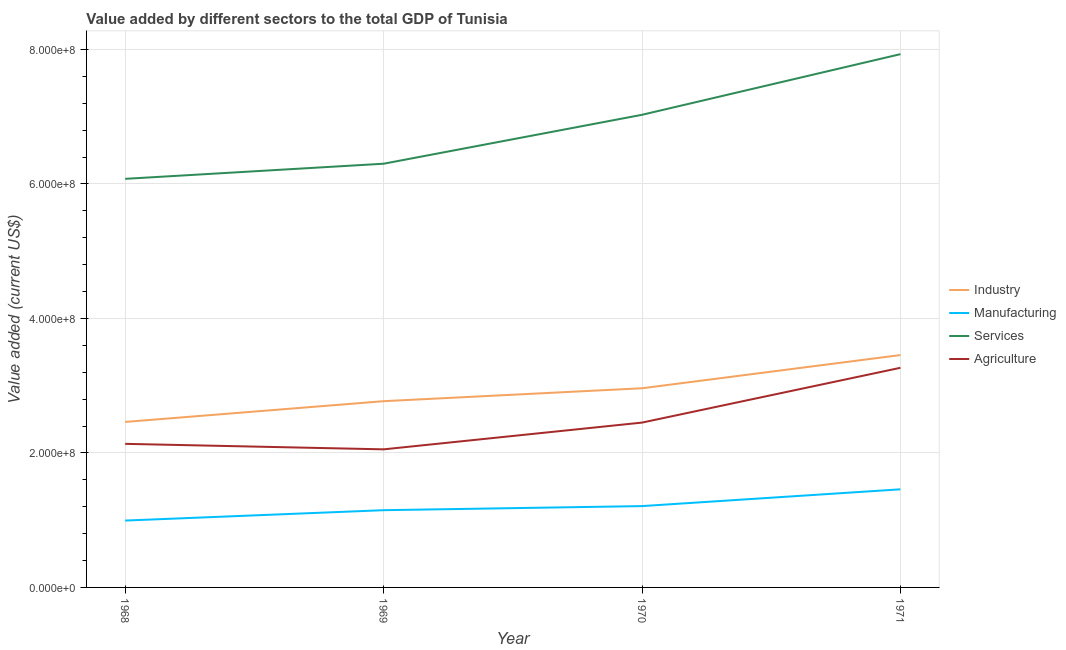Does the line corresponding to value added by services sector intersect with the line corresponding to value added by agricultural sector?
Your response must be concise. No. Is the number of lines equal to the number of legend labels?
Provide a succinct answer. Yes. What is the value added by manufacturing sector in 1968?
Keep it short and to the point. 9.94e+07. Across all years, what is the maximum value added by agricultural sector?
Give a very brief answer. 3.27e+08. Across all years, what is the minimum value added by manufacturing sector?
Give a very brief answer. 9.94e+07. In which year was the value added by manufacturing sector minimum?
Provide a short and direct response. 1968. What is the total value added by manufacturing sector in the graph?
Your answer should be very brief. 4.81e+08. What is the difference between the value added by agricultural sector in 1968 and that in 1970?
Provide a short and direct response. -3.16e+07. What is the difference between the value added by agricultural sector in 1971 and the value added by services sector in 1968?
Your response must be concise. -2.81e+08. What is the average value added by industrial sector per year?
Your answer should be very brief. 2.91e+08. In the year 1968, what is the difference between the value added by manufacturing sector and value added by services sector?
Give a very brief answer. -5.08e+08. What is the ratio of the value added by industrial sector in 1969 to that in 1971?
Your answer should be very brief. 0.8. Is the value added by agricultural sector in 1968 less than that in 1970?
Give a very brief answer. Yes. Is the difference between the value added by manufacturing sector in 1968 and 1969 greater than the difference between the value added by industrial sector in 1968 and 1969?
Offer a very short reply. Yes. What is the difference between the highest and the second highest value added by services sector?
Your response must be concise. 9.02e+07. What is the difference between the highest and the lowest value added by industrial sector?
Your response must be concise. 9.95e+07. In how many years, is the value added by agricultural sector greater than the average value added by agricultural sector taken over all years?
Offer a terse response. 1. Is the sum of the value added by services sector in 1969 and 1970 greater than the maximum value added by agricultural sector across all years?
Keep it short and to the point. Yes. Is it the case that in every year, the sum of the value added by agricultural sector and value added by services sector is greater than the sum of value added by manufacturing sector and value added by industrial sector?
Give a very brief answer. Yes. Is the value added by industrial sector strictly greater than the value added by services sector over the years?
Offer a terse response. No. How many years are there in the graph?
Keep it short and to the point. 4. What is the difference between two consecutive major ticks on the Y-axis?
Ensure brevity in your answer.  2.00e+08. Does the graph contain any zero values?
Ensure brevity in your answer.  No. Does the graph contain grids?
Offer a very short reply. Yes. How many legend labels are there?
Ensure brevity in your answer.  4. What is the title of the graph?
Make the answer very short. Value added by different sectors to the total GDP of Tunisia. What is the label or title of the Y-axis?
Your response must be concise. Value added (current US$). What is the Value added (current US$) of Industry in 1968?
Your answer should be compact. 2.46e+08. What is the Value added (current US$) of Manufacturing in 1968?
Ensure brevity in your answer.  9.94e+07. What is the Value added (current US$) of Services in 1968?
Make the answer very short. 6.08e+08. What is the Value added (current US$) of Agriculture in 1968?
Provide a succinct answer. 2.14e+08. What is the Value added (current US$) in Industry in 1969?
Make the answer very short. 2.77e+08. What is the Value added (current US$) in Manufacturing in 1969?
Give a very brief answer. 1.15e+08. What is the Value added (current US$) in Services in 1969?
Make the answer very short. 6.30e+08. What is the Value added (current US$) in Agriculture in 1969?
Your answer should be very brief. 2.05e+08. What is the Value added (current US$) in Industry in 1970?
Make the answer very short. 2.96e+08. What is the Value added (current US$) of Manufacturing in 1970?
Offer a terse response. 1.21e+08. What is the Value added (current US$) in Services in 1970?
Your answer should be very brief. 7.03e+08. What is the Value added (current US$) of Agriculture in 1970?
Provide a succinct answer. 2.45e+08. What is the Value added (current US$) in Industry in 1971?
Make the answer very short. 3.46e+08. What is the Value added (current US$) in Manufacturing in 1971?
Provide a succinct answer. 1.46e+08. What is the Value added (current US$) in Services in 1971?
Your response must be concise. 7.93e+08. What is the Value added (current US$) of Agriculture in 1971?
Ensure brevity in your answer.  3.27e+08. Across all years, what is the maximum Value added (current US$) of Industry?
Give a very brief answer. 3.46e+08. Across all years, what is the maximum Value added (current US$) of Manufacturing?
Give a very brief answer. 1.46e+08. Across all years, what is the maximum Value added (current US$) in Services?
Offer a terse response. 7.93e+08. Across all years, what is the maximum Value added (current US$) of Agriculture?
Ensure brevity in your answer.  3.27e+08. Across all years, what is the minimum Value added (current US$) of Industry?
Give a very brief answer. 2.46e+08. Across all years, what is the minimum Value added (current US$) in Manufacturing?
Give a very brief answer. 9.94e+07. Across all years, what is the minimum Value added (current US$) in Services?
Keep it short and to the point. 6.08e+08. Across all years, what is the minimum Value added (current US$) in Agriculture?
Provide a short and direct response. 2.05e+08. What is the total Value added (current US$) in Industry in the graph?
Offer a terse response. 1.16e+09. What is the total Value added (current US$) of Manufacturing in the graph?
Offer a terse response. 4.81e+08. What is the total Value added (current US$) of Services in the graph?
Offer a terse response. 2.73e+09. What is the total Value added (current US$) in Agriculture in the graph?
Offer a very short reply. 9.91e+08. What is the difference between the Value added (current US$) in Industry in 1968 and that in 1969?
Your answer should be very brief. -3.09e+07. What is the difference between the Value added (current US$) of Manufacturing in 1968 and that in 1969?
Offer a very short reply. -1.54e+07. What is the difference between the Value added (current US$) of Services in 1968 and that in 1969?
Make the answer very short. -2.25e+07. What is the difference between the Value added (current US$) of Agriculture in 1968 and that in 1969?
Make the answer very short. 8.19e+06. What is the difference between the Value added (current US$) in Industry in 1968 and that in 1970?
Your answer should be compact. -5.01e+07. What is the difference between the Value added (current US$) in Manufacturing in 1968 and that in 1970?
Your answer should be very brief. -2.15e+07. What is the difference between the Value added (current US$) of Services in 1968 and that in 1970?
Your response must be concise. -9.52e+07. What is the difference between the Value added (current US$) of Agriculture in 1968 and that in 1970?
Provide a short and direct response. -3.16e+07. What is the difference between the Value added (current US$) of Industry in 1968 and that in 1971?
Offer a very short reply. -9.95e+07. What is the difference between the Value added (current US$) in Manufacturing in 1968 and that in 1971?
Make the answer very short. -4.65e+07. What is the difference between the Value added (current US$) in Services in 1968 and that in 1971?
Provide a short and direct response. -1.85e+08. What is the difference between the Value added (current US$) of Agriculture in 1968 and that in 1971?
Provide a short and direct response. -1.13e+08. What is the difference between the Value added (current US$) in Industry in 1969 and that in 1970?
Your answer should be very brief. -1.92e+07. What is the difference between the Value added (current US$) in Manufacturing in 1969 and that in 1970?
Offer a terse response. -6.10e+06. What is the difference between the Value added (current US$) of Services in 1969 and that in 1970?
Your response must be concise. -7.28e+07. What is the difference between the Value added (current US$) in Agriculture in 1969 and that in 1970?
Your response must be concise. -3.98e+07. What is the difference between the Value added (current US$) of Industry in 1969 and that in 1971?
Provide a succinct answer. -6.86e+07. What is the difference between the Value added (current US$) in Manufacturing in 1969 and that in 1971?
Keep it short and to the point. -3.11e+07. What is the difference between the Value added (current US$) in Services in 1969 and that in 1971?
Keep it short and to the point. -1.63e+08. What is the difference between the Value added (current US$) in Agriculture in 1969 and that in 1971?
Your answer should be very brief. -1.21e+08. What is the difference between the Value added (current US$) of Industry in 1970 and that in 1971?
Give a very brief answer. -4.94e+07. What is the difference between the Value added (current US$) of Manufacturing in 1970 and that in 1971?
Keep it short and to the point. -2.50e+07. What is the difference between the Value added (current US$) of Services in 1970 and that in 1971?
Offer a terse response. -9.02e+07. What is the difference between the Value added (current US$) of Agriculture in 1970 and that in 1971?
Your response must be concise. -8.15e+07. What is the difference between the Value added (current US$) of Industry in 1968 and the Value added (current US$) of Manufacturing in 1969?
Keep it short and to the point. 1.31e+08. What is the difference between the Value added (current US$) in Industry in 1968 and the Value added (current US$) in Services in 1969?
Provide a succinct answer. -3.84e+08. What is the difference between the Value added (current US$) of Industry in 1968 and the Value added (current US$) of Agriculture in 1969?
Ensure brevity in your answer.  4.08e+07. What is the difference between the Value added (current US$) of Manufacturing in 1968 and the Value added (current US$) of Services in 1969?
Provide a succinct answer. -5.31e+08. What is the difference between the Value added (current US$) in Manufacturing in 1968 and the Value added (current US$) in Agriculture in 1969?
Give a very brief answer. -1.06e+08. What is the difference between the Value added (current US$) of Services in 1968 and the Value added (current US$) of Agriculture in 1969?
Provide a succinct answer. 4.02e+08. What is the difference between the Value added (current US$) of Industry in 1968 and the Value added (current US$) of Manufacturing in 1970?
Your answer should be very brief. 1.25e+08. What is the difference between the Value added (current US$) in Industry in 1968 and the Value added (current US$) in Services in 1970?
Offer a terse response. -4.57e+08. What is the difference between the Value added (current US$) in Industry in 1968 and the Value added (current US$) in Agriculture in 1970?
Ensure brevity in your answer.  9.52e+05. What is the difference between the Value added (current US$) of Manufacturing in 1968 and the Value added (current US$) of Services in 1970?
Provide a succinct answer. -6.03e+08. What is the difference between the Value added (current US$) of Manufacturing in 1968 and the Value added (current US$) of Agriculture in 1970?
Offer a very short reply. -1.46e+08. What is the difference between the Value added (current US$) in Services in 1968 and the Value added (current US$) in Agriculture in 1970?
Your answer should be very brief. 3.62e+08. What is the difference between the Value added (current US$) in Industry in 1968 and the Value added (current US$) in Manufacturing in 1971?
Offer a terse response. 1.00e+08. What is the difference between the Value added (current US$) in Industry in 1968 and the Value added (current US$) in Services in 1971?
Give a very brief answer. -5.47e+08. What is the difference between the Value added (current US$) of Industry in 1968 and the Value added (current US$) of Agriculture in 1971?
Keep it short and to the point. -8.05e+07. What is the difference between the Value added (current US$) in Manufacturing in 1968 and the Value added (current US$) in Services in 1971?
Your answer should be compact. -6.94e+08. What is the difference between the Value added (current US$) of Manufacturing in 1968 and the Value added (current US$) of Agriculture in 1971?
Make the answer very short. -2.27e+08. What is the difference between the Value added (current US$) of Services in 1968 and the Value added (current US$) of Agriculture in 1971?
Give a very brief answer. 2.81e+08. What is the difference between the Value added (current US$) in Industry in 1969 and the Value added (current US$) in Manufacturing in 1970?
Offer a very short reply. 1.56e+08. What is the difference between the Value added (current US$) in Industry in 1969 and the Value added (current US$) in Services in 1970?
Make the answer very short. -4.26e+08. What is the difference between the Value added (current US$) of Industry in 1969 and the Value added (current US$) of Agriculture in 1970?
Ensure brevity in your answer.  3.18e+07. What is the difference between the Value added (current US$) of Manufacturing in 1969 and the Value added (current US$) of Services in 1970?
Make the answer very short. -5.88e+08. What is the difference between the Value added (current US$) in Manufacturing in 1969 and the Value added (current US$) in Agriculture in 1970?
Make the answer very short. -1.30e+08. What is the difference between the Value added (current US$) in Services in 1969 and the Value added (current US$) in Agriculture in 1970?
Keep it short and to the point. 3.85e+08. What is the difference between the Value added (current US$) in Industry in 1969 and the Value added (current US$) in Manufacturing in 1971?
Your answer should be very brief. 1.31e+08. What is the difference between the Value added (current US$) in Industry in 1969 and the Value added (current US$) in Services in 1971?
Offer a very short reply. -5.16e+08. What is the difference between the Value added (current US$) of Industry in 1969 and the Value added (current US$) of Agriculture in 1971?
Your response must be concise. -4.97e+07. What is the difference between the Value added (current US$) in Manufacturing in 1969 and the Value added (current US$) in Services in 1971?
Your answer should be compact. -6.78e+08. What is the difference between the Value added (current US$) of Manufacturing in 1969 and the Value added (current US$) of Agriculture in 1971?
Your response must be concise. -2.12e+08. What is the difference between the Value added (current US$) in Services in 1969 and the Value added (current US$) in Agriculture in 1971?
Provide a short and direct response. 3.03e+08. What is the difference between the Value added (current US$) of Industry in 1970 and the Value added (current US$) of Manufacturing in 1971?
Provide a short and direct response. 1.50e+08. What is the difference between the Value added (current US$) in Industry in 1970 and the Value added (current US$) in Services in 1971?
Your answer should be compact. -4.97e+08. What is the difference between the Value added (current US$) in Industry in 1970 and the Value added (current US$) in Agriculture in 1971?
Your answer should be compact. -3.04e+07. What is the difference between the Value added (current US$) of Manufacturing in 1970 and the Value added (current US$) of Services in 1971?
Your response must be concise. -6.72e+08. What is the difference between the Value added (current US$) of Manufacturing in 1970 and the Value added (current US$) of Agriculture in 1971?
Your answer should be compact. -2.06e+08. What is the difference between the Value added (current US$) in Services in 1970 and the Value added (current US$) in Agriculture in 1971?
Offer a terse response. 3.76e+08. What is the average Value added (current US$) of Industry per year?
Give a very brief answer. 2.91e+08. What is the average Value added (current US$) in Manufacturing per year?
Ensure brevity in your answer.  1.20e+08. What is the average Value added (current US$) in Services per year?
Ensure brevity in your answer.  6.83e+08. What is the average Value added (current US$) in Agriculture per year?
Offer a very short reply. 2.48e+08. In the year 1968, what is the difference between the Value added (current US$) in Industry and Value added (current US$) in Manufacturing?
Offer a very short reply. 1.47e+08. In the year 1968, what is the difference between the Value added (current US$) in Industry and Value added (current US$) in Services?
Give a very brief answer. -3.62e+08. In the year 1968, what is the difference between the Value added (current US$) in Industry and Value added (current US$) in Agriculture?
Your response must be concise. 3.26e+07. In the year 1968, what is the difference between the Value added (current US$) of Manufacturing and Value added (current US$) of Services?
Offer a terse response. -5.08e+08. In the year 1968, what is the difference between the Value added (current US$) in Manufacturing and Value added (current US$) in Agriculture?
Your response must be concise. -1.14e+08. In the year 1968, what is the difference between the Value added (current US$) of Services and Value added (current US$) of Agriculture?
Make the answer very short. 3.94e+08. In the year 1969, what is the difference between the Value added (current US$) of Industry and Value added (current US$) of Manufacturing?
Your answer should be compact. 1.62e+08. In the year 1969, what is the difference between the Value added (current US$) in Industry and Value added (current US$) in Services?
Your answer should be compact. -3.53e+08. In the year 1969, what is the difference between the Value added (current US$) of Industry and Value added (current US$) of Agriculture?
Your response must be concise. 7.16e+07. In the year 1969, what is the difference between the Value added (current US$) of Manufacturing and Value added (current US$) of Services?
Your response must be concise. -5.15e+08. In the year 1969, what is the difference between the Value added (current US$) in Manufacturing and Value added (current US$) in Agriculture?
Your answer should be compact. -9.05e+07. In the year 1969, what is the difference between the Value added (current US$) of Services and Value added (current US$) of Agriculture?
Provide a succinct answer. 4.25e+08. In the year 1970, what is the difference between the Value added (current US$) of Industry and Value added (current US$) of Manufacturing?
Provide a short and direct response. 1.75e+08. In the year 1970, what is the difference between the Value added (current US$) of Industry and Value added (current US$) of Services?
Offer a very short reply. -4.07e+08. In the year 1970, what is the difference between the Value added (current US$) of Industry and Value added (current US$) of Agriculture?
Provide a succinct answer. 5.10e+07. In the year 1970, what is the difference between the Value added (current US$) of Manufacturing and Value added (current US$) of Services?
Your answer should be very brief. -5.82e+08. In the year 1970, what is the difference between the Value added (current US$) in Manufacturing and Value added (current US$) in Agriculture?
Provide a succinct answer. -1.24e+08. In the year 1970, what is the difference between the Value added (current US$) in Services and Value added (current US$) in Agriculture?
Keep it short and to the point. 4.58e+08. In the year 1971, what is the difference between the Value added (current US$) of Industry and Value added (current US$) of Manufacturing?
Your response must be concise. 2.00e+08. In the year 1971, what is the difference between the Value added (current US$) of Industry and Value added (current US$) of Services?
Your answer should be very brief. -4.47e+08. In the year 1971, what is the difference between the Value added (current US$) in Industry and Value added (current US$) in Agriculture?
Your answer should be very brief. 1.89e+07. In the year 1971, what is the difference between the Value added (current US$) of Manufacturing and Value added (current US$) of Services?
Your response must be concise. -6.47e+08. In the year 1971, what is the difference between the Value added (current US$) of Manufacturing and Value added (current US$) of Agriculture?
Your answer should be compact. -1.81e+08. In the year 1971, what is the difference between the Value added (current US$) in Services and Value added (current US$) in Agriculture?
Keep it short and to the point. 4.66e+08. What is the ratio of the Value added (current US$) in Industry in 1968 to that in 1969?
Offer a terse response. 0.89. What is the ratio of the Value added (current US$) of Manufacturing in 1968 to that in 1969?
Provide a succinct answer. 0.87. What is the ratio of the Value added (current US$) of Agriculture in 1968 to that in 1969?
Ensure brevity in your answer.  1.04. What is the ratio of the Value added (current US$) in Industry in 1968 to that in 1970?
Your answer should be compact. 0.83. What is the ratio of the Value added (current US$) of Manufacturing in 1968 to that in 1970?
Offer a terse response. 0.82. What is the ratio of the Value added (current US$) of Services in 1968 to that in 1970?
Your response must be concise. 0.86. What is the ratio of the Value added (current US$) of Agriculture in 1968 to that in 1970?
Provide a short and direct response. 0.87. What is the ratio of the Value added (current US$) in Industry in 1968 to that in 1971?
Provide a succinct answer. 0.71. What is the ratio of the Value added (current US$) of Manufacturing in 1968 to that in 1971?
Your answer should be compact. 0.68. What is the ratio of the Value added (current US$) in Services in 1968 to that in 1971?
Offer a terse response. 0.77. What is the ratio of the Value added (current US$) of Agriculture in 1968 to that in 1971?
Provide a short and direct response. 0.65. What is the ratio of the Value added (current US$) in Industry in 1969 to that in 1970?
Offer a terse response. 0.94. What is the ratio of the Value added (current US$) in Manufacturing in 1969 to that in 1970?
Your answer should be compact. 0.95. What is the ratio of the Value added (current US$) in Services in 1969 to that in 1970?
Provide a short and direct response. 0.9. What is the ratio of the Value added (current US$) in Agriculture in 1969 to that in 1970?
Offer a terse response. 0.84. What is the ratio of the Value added (current US$) in Industry in 1969 to that in 1971?
Offer a very short reply. 0.8. What is the ratio of the Value added (current US$) in Manufacturing in 1969 to that in 1971?
Your answer should be very brief. 0.79. What is the ratio of the Value added (current US$) of Services in 1969 to that in 1971?
Your answer should be compact. 0.79. What is the ratio of the Value added (current US$) of Agriculture in 1969 to that in 1971?
Your answer should be compact. 0.63. What is the ratio of the Value added (current US$) in Manufacturing in 1970 to that in 1971?
Your answer should be compact. 0.83. What is the ratio of the Value added (current US$) of Services in 1970 to that in 1971?
Offer a very short reply. 0.89. What is the ratio of the Value added (current US$) of Agriculture in 1970 to that in 1971?
Provide a succinct answer. 0.75. What is the difference between the highest and the second highest Value added (current US$) of Industry?
Keep it short and to the point. 4.94e+07. What is the difference between the highest and the second highest Value added (current US$) of Manufacturing?
Your answer should be very brief. 2.50e+07. What is the difference between the highest and the second highest Value added (current US$) in Services?
Keep it short and to the point. 9.02e+07. What is the difference between the highest and the second highest Value added (current US$) of Agriculture?
Keep it short and to the point. 8.15e+07. What is the difference between the highest and the lowest Value added (current US$) in Industry?
Give a very brief answer. 9.95e+07. What is the difference between the highest and the lowest Value added (current US$) of Manufacturing?
Offer a very short reply. 4.65e+07. What is the difference between the highest and the lowest Value added (current US$) in Services?
Give a very brief answer. 1.85e+08. What is the difference between the highest and the lowest Value added (current US$) in Agriculture?
Ensure brevity in your answer.  1.21e+08. 